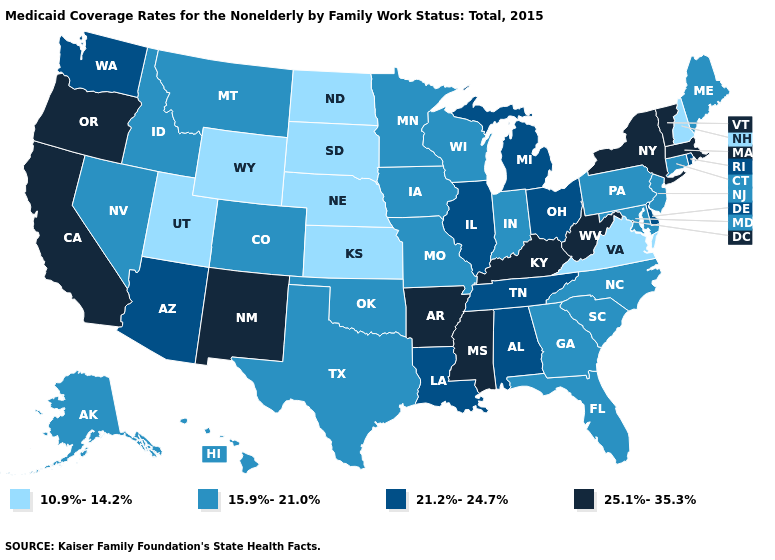Does Pennsylvania have the highest value in the Northeast?
Keep it brief. No. What is the lowest value in the Northeast?
Write a very short answer. 10.9%-14.2%. Does Rhode Island have the same value as Washington?
Concise answer only. Yes. Does Oregon have the highest value in the West?
Give a very brief answer. Yes. What is the value of Montana?
Keep it brief. 15.9%-21.0%. Does Illinois have the highest value in the MidWest?
Short answer required. Yes. Does Kentucky have the highest value in the South?
Short answer required. Yes. Among the states that border Arkansas , which have the lowest value?
Keep it brief. Missouri, Oklahoma, Texas. What is the value of Arkansas?
Answer briefly. 25.1%-35.3%. Does Virginia have the lowest value in the South?
Be succinct. Yes. What is the value of Kentucky?
Quick response, please. 25.1%-35.3%. How many symbols are there in the legend?
Quick response, please. 4. What is the value of South Carolina?
Short answer required. 15.9%-21.0%. Which states have the lowest value in the USA?
Be succinct. Kansas, Nebraska, New Hampshire, North Dakota, South Dakota, Utah, Virginia, Wyoming. Does Georgia have the highest value in the USA?
Write a very short answer. No. 